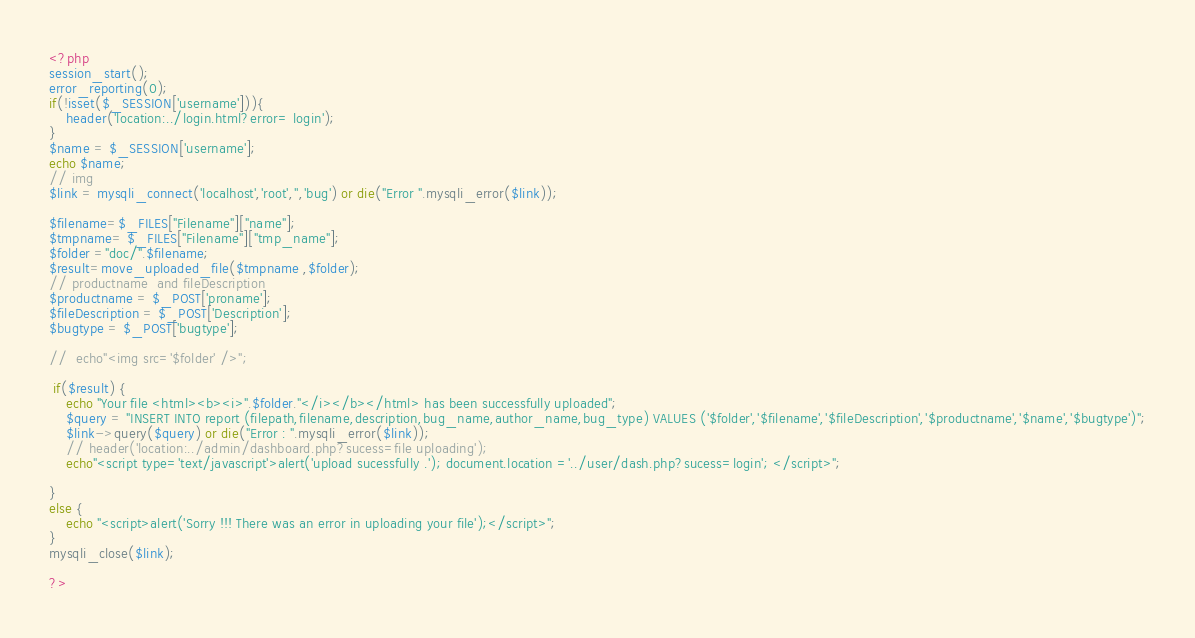<code> <loc_0><loc_0><loc_500><loc_500><_PHP_><?php
session_start();
error_reporting(0);
if(!isset($_SESSION['username'])){
    header('location:../login.html?error= login');
}
$name = $_SESSION['username'];
echo $name;
// img 
$link = mysqli_connect('localhost','root','','bug') or die("Error ".mysqli_error($link));

$filename=$_FILES["Filename"]["name"];
$tmpname= $_FILES["Filename"]["tmp_name"]; 
$folder ="doc/".$filename;
$result=move_uploaded_file($tmpname ,$folder);
// productname  and fileDescription
$productname = $_POST['proname'];
$fileDescription = $_POST['Description'];
$bugtype = $_POST['bugtype'];

//  echo"<img src='$folder' />";

 if($result) { 
    echo "Your file <html><b><i>".$folder."</i></b></html> has been successfully uploaded";       
    $query = "INSERT INTO report (filepath,filename,description,bug_name,author_name,bug_type) VALUES ('$folder','$filename','$fileDescription','$productname','$name','$bugtype')";
    $link->query($query) or die("Error : ".mysqli_error($link));
    // header('location:../admin/dashboard.php?sucess=file uploading');
    echo"<script type='text/javascript'>alert('upload sucessfully .'); document.location ='../user/dash.php?sucess=login'; </script>";
                
}
else {          
    echo "<script>alert('Sorry !!! There was an error in uploading your file');</script>";         
}
mysqli_close($link);

?>
</code> 